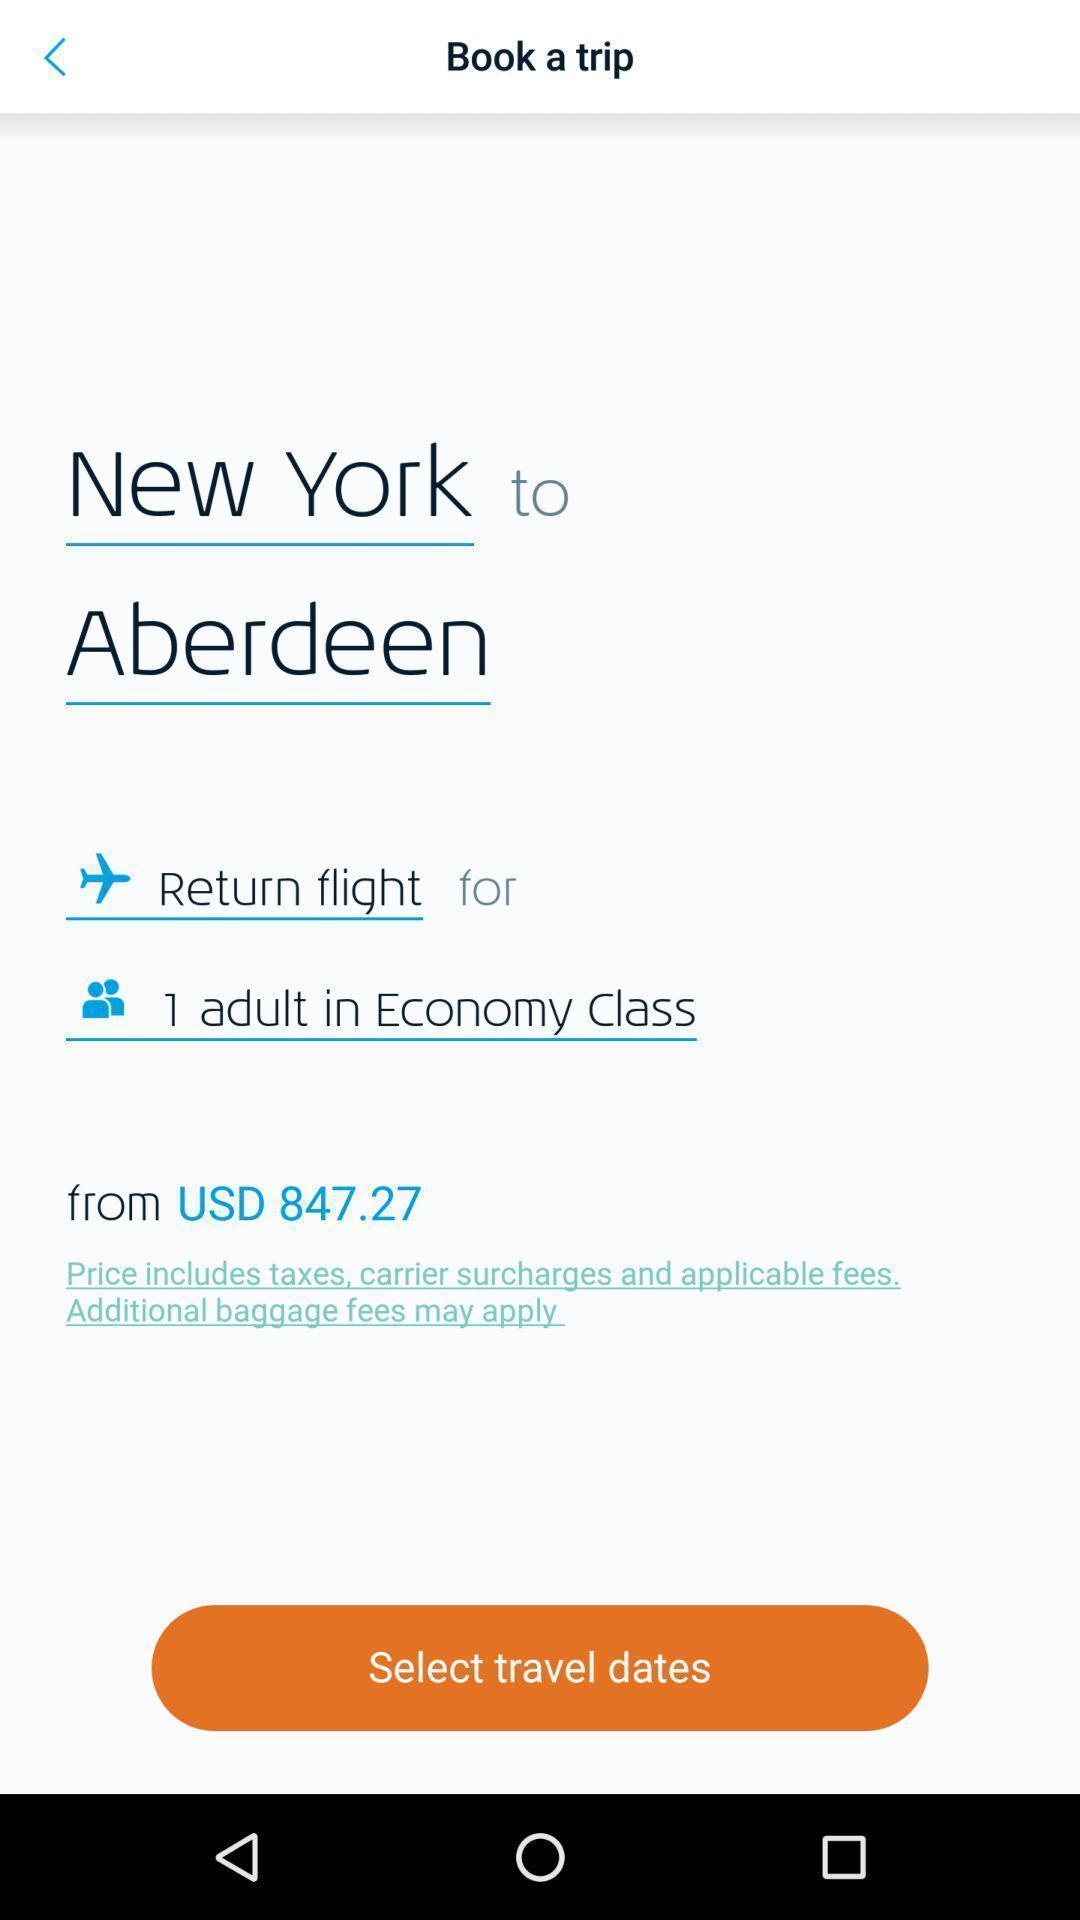What is the overall content of this screenshot? Page to book a trip in travel and local app. 